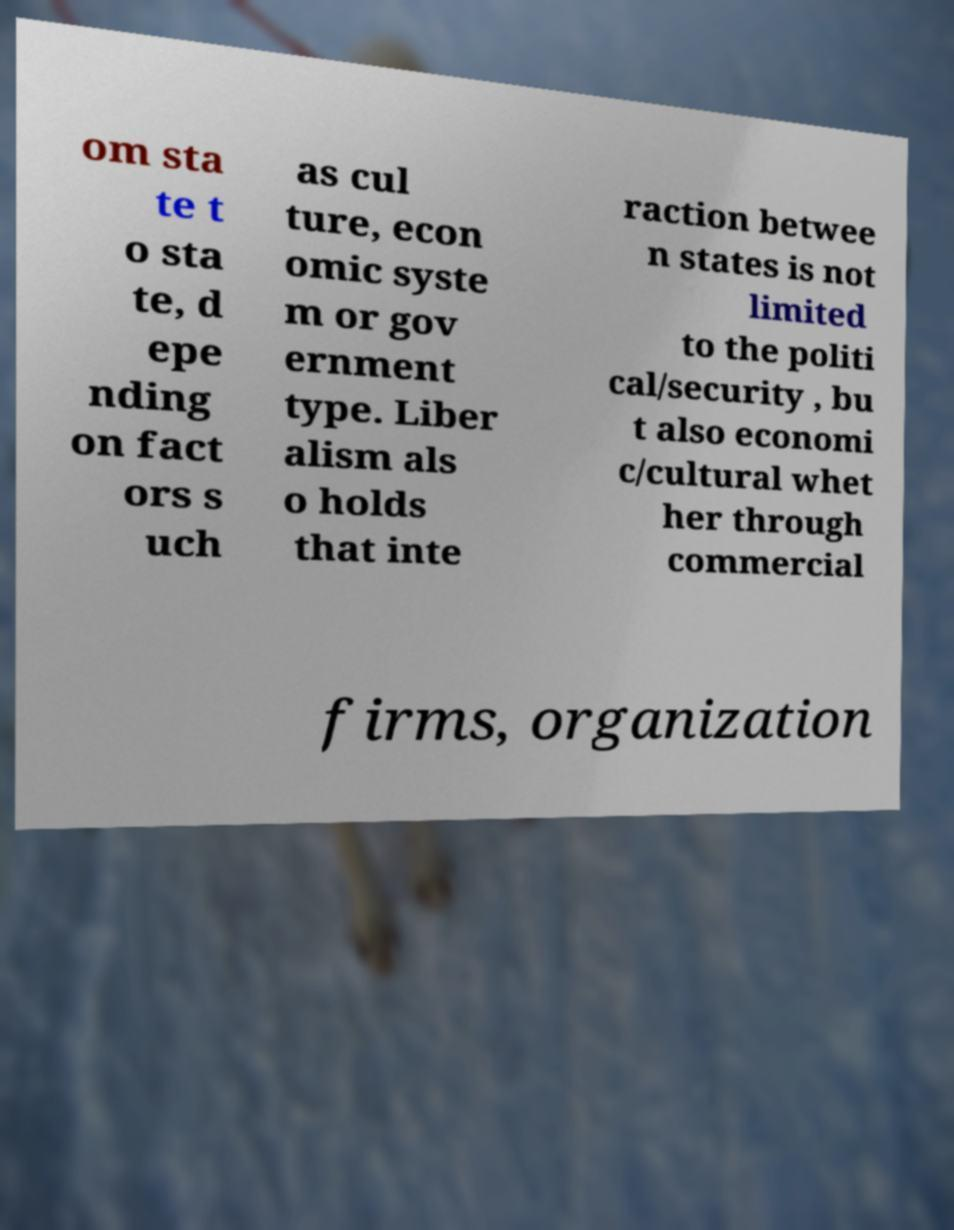Please identify and transcribe the text found in this image. om sta te t o sta te, d epe nding on fact ors s uch as cul ture, econ omic syste m or gov ernment type. Liber alism als o holds that inte raction betwee n states is not limited to the politi cal/security , bu t also economi c/cultural whet her through commercial firms, organization 